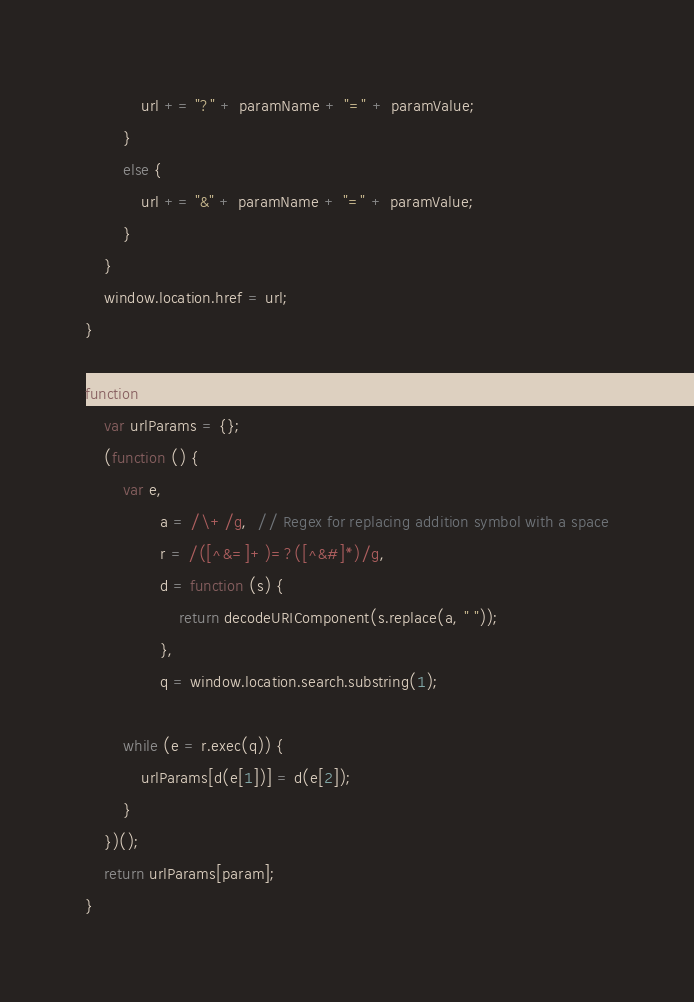Convert code to text. <code><loc_0><loc_0><loc_500><loc_500><_JavaScript_>            url += "?" + paramName + "=" + paramValue;
        }
        else {
            url += "&" + paramName + "=" + paramValue;
        }
    }
    window.location.href = url;
}

function getQueryParam(param) {
    var urlParams = {};
    (function () {
        var e,
                a = /\+/g,  // Regex for replacing addition symbol with a space
                r = /([^&=]+)=?([^&#]*)/g,
                d = function (s) {
                    return decodeURIComponent(s.replace(a, " "));
                },
                q = window.location.search.substring(1);

        while (e = r.exec(q)) {
            urlParams[d(e[1])] = d(e[2]);
        }
    })();
    return urlParams[param];
}</code> 